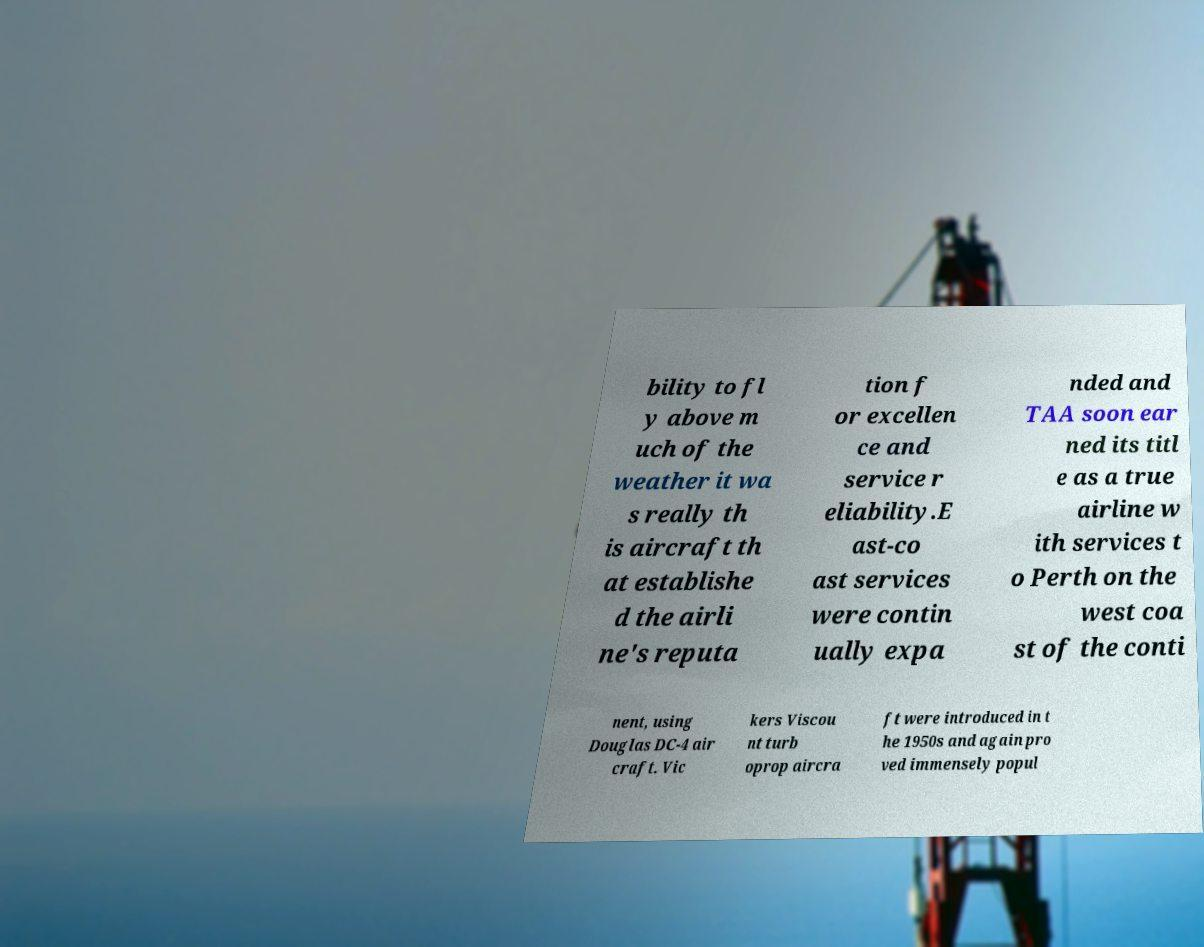There's text embedded in this image that I need extracted. Can you transcribe it verbatim? bility to fl y above m uch of the weather it wa s really th is aircraft th at establishe d the airli ne's reputa tion f or excellen ce and service r eliability.E ast-co ast services were contin ually expa nded and TAA soon ear ned its titl e as a true airline w ith services t o Perth on the west coa st of the conti nent, using Douglas DC-4 air craft. Vic kers Viscou nt turb oprop aircra ft were introduced in t he 1950s and again pro ved immensely popul 